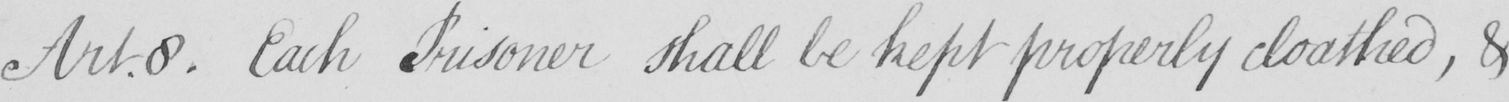What does this handwritten line say? Art.8 . Each Prisoner shall be kept properly cloathed , & 